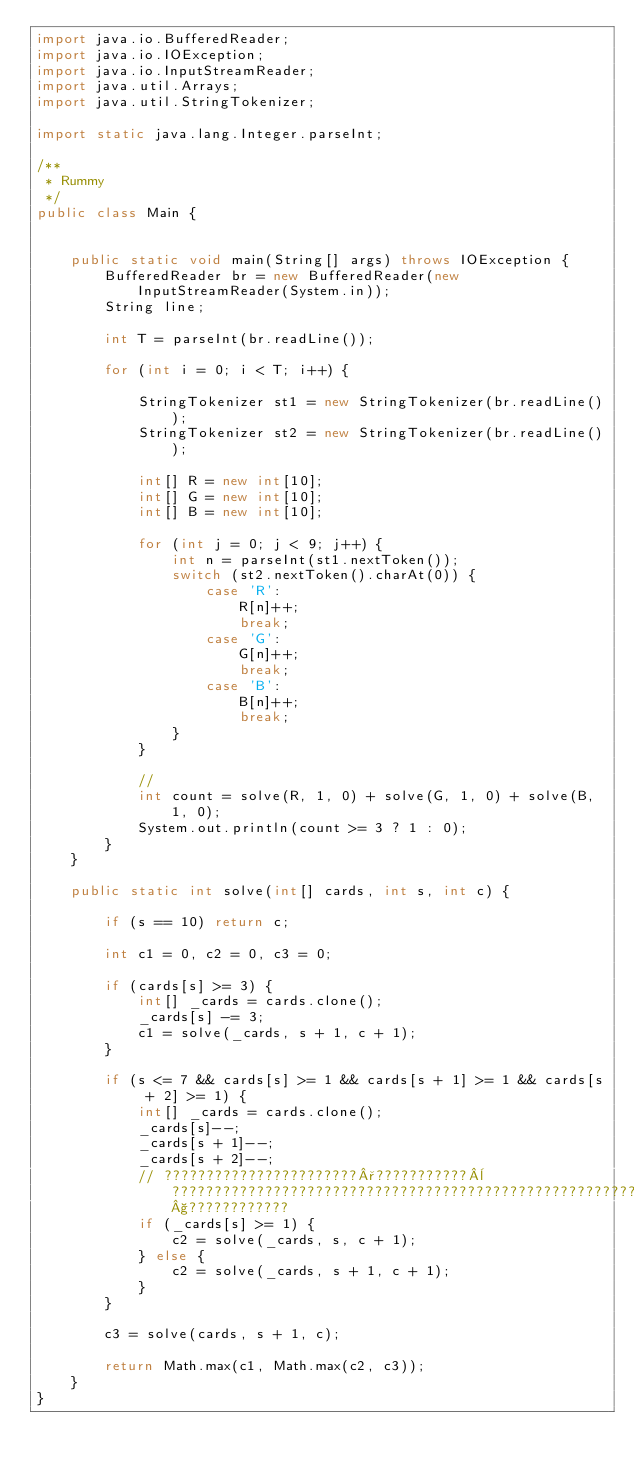<code> <loc_0><loc_0><loc_500><loc_500><_Java_>import java.io.BufferedReader;
import java.io.IOException;
import java.io.InputStreamReader;
import java.util.Arrays;
import java.util.StringTokenizer;

import static java.lang.Integer.parseInt;

/**
 * Rummy
 */
public class Main {


	public static void main(String[] args) throws IOException {
		BufferedReader br = new BufferedReader(new InputStreamReader(System.in));
		String line;

		int T = parseInt(br.readLine());

		for (int i = 0; i < T; i++) {

			StringTokenizer st1 = new StringTokenizer(br.readLine());
			StringTokenizer st2 = new StringTokenizer(br.readLine());

			int[] R = new int[10];
			int[] G = new int[10];
			int[] B = new int[10];

			for (int j = 0; j < 9; j++) {
				int n = parseInt(st1.nextToken());
				switch (st2.nextToken().charAt(0)) {
					case 'R':
						R[n]++;
						break;
					case 'G':
						G[n]++;
						break;
					case 'B':
						B[n]++;
						break;
				}
			}

			//
			int count = solve(R, 1, 0) + solve(G, 1, 0) + solve(B, 1, 0);
			System.out.println(count >= 3 ? 1 : 0);
		}
	}

	public static int solve(int[] cards, int s, int c) {

		if (s == 10) return c;

		int c1 = 0, c2 = 0, c3 = 0;

		if (cards[s] >= 3) {
			int[] _cards = cards.clone();
			_cards[s] -= 3;
			c1 = solve(_cards, s + 1, c + 1);
		}

		if (s <= 7 && cards[s] >= 1 && cards[s + 1] >= 1 && cards[s + 2] >= 1) {
			int[] _cards = cards.clone();
			_cards[s]--;
			_cards[s + 1]--;
			_cards[s + 2]--;
			// ???????????????????????°???????????¨???????????????????????????????????????????????????????????§????????????
			if (_cards[s] >= 1) {
				c2 = solve(_cards, s, c + 1);
			} else {
				c2 = solve(_cards, s + 1, c + 1);
			}
		}

		c3 = solve(cards, s + 1, c);

		return Math.max(c1, Math.max(c2, c3));
	}
}</code> 